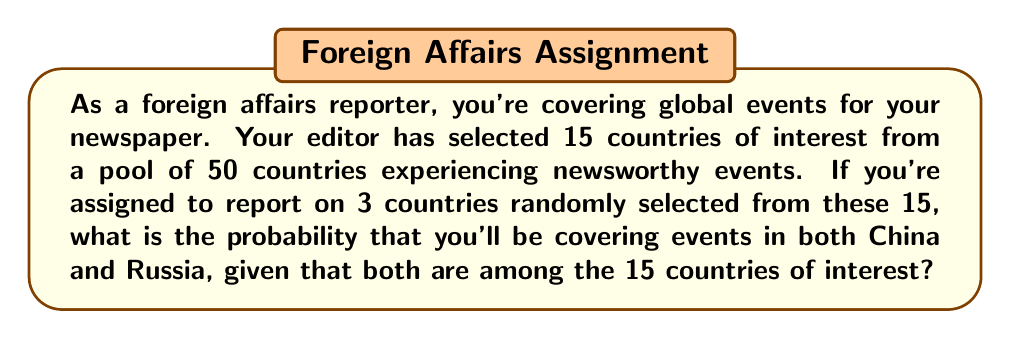Solve this math problem. Let's approach this step-by-step:

1) First, we need to calculate the total number of ways to select 3 countries from 15. This is a combination problem, represented as $\binom{15}{3}$ or $C(15,3)$.

   $$\binom{15}{3} = \frac{15!}{3!(15-3)!} = \frac{15!}{3!12!} = 455$$

2) Now, we need to calculate the number of ways to select China, Russia, and one other country from the remaining 13 countries. This is equivalent to $\binom{13}{1}$.

   $$\binom{13}{1} = 13$$

3) The probability is then the number of favorable outcomes divided by the total number of possible outcomes:

   $$P(\text{China and Russia}) = \frac{\text{Number of ways to select China, Russia, and one other}}{\text{Total number of ways to select 3 countries from 15}}$$

   $$P(\text{China and Russia}) = \frac{\binom{13}{1}}{\binom{15}{3}} = \frac{13}{455}$$

4) To simplify this fraction:

   $$\frac{13}{455} = \frac{13}{455} = \frac{1}{35}$$

Therefore, the probability of covering both China and Russia is $\frac{1}{35}$.
Answer: $\frac{1}{35}$ or approximately 0.0286 or 2.86% 